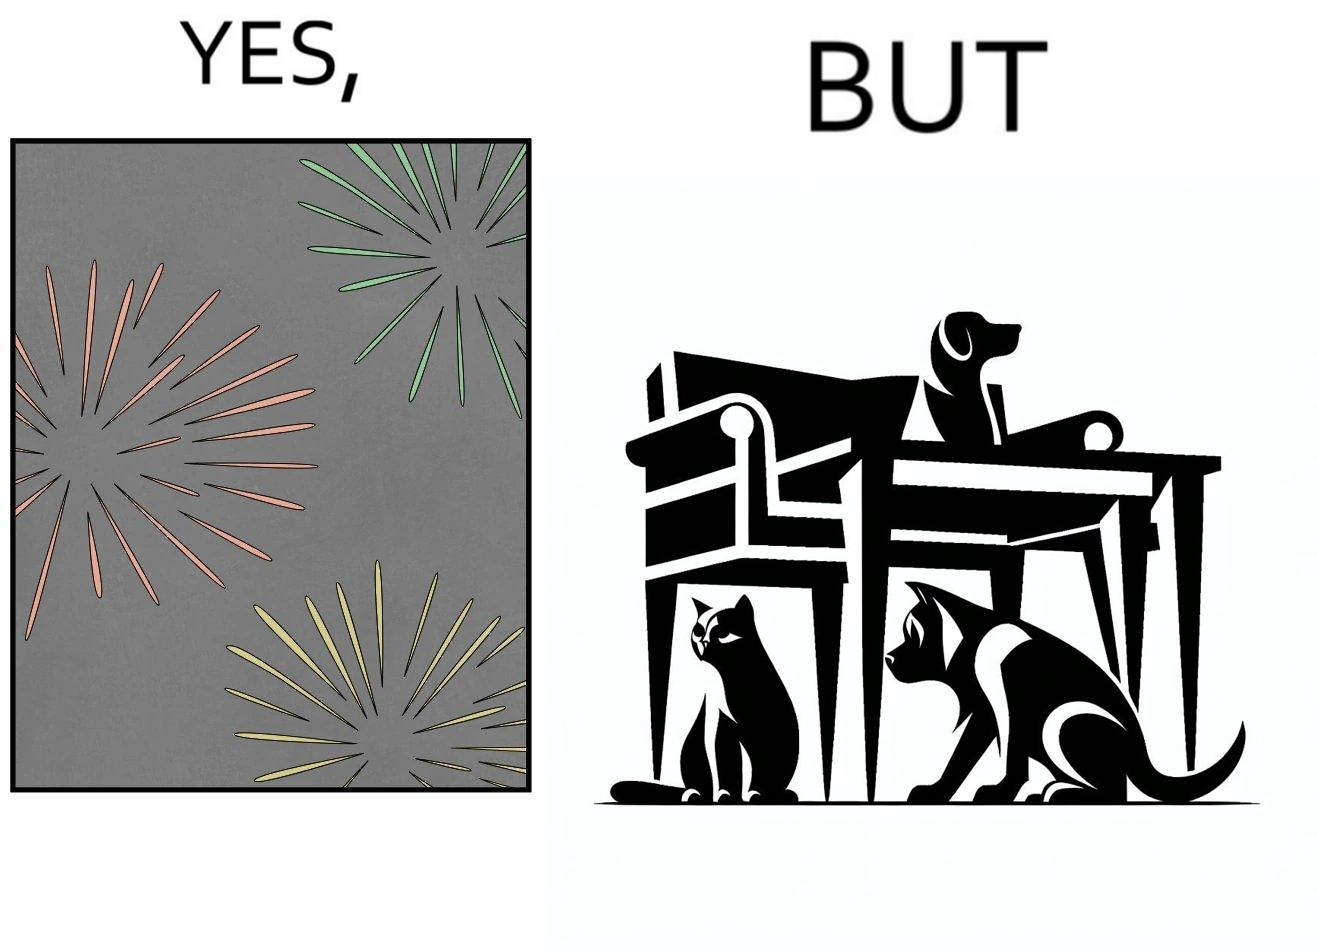Describe the satirical element in this image. The image is satirical because while firecrackers in the sky look pretty, not everyone likes them. Animals are very scared of the firecrackers. 